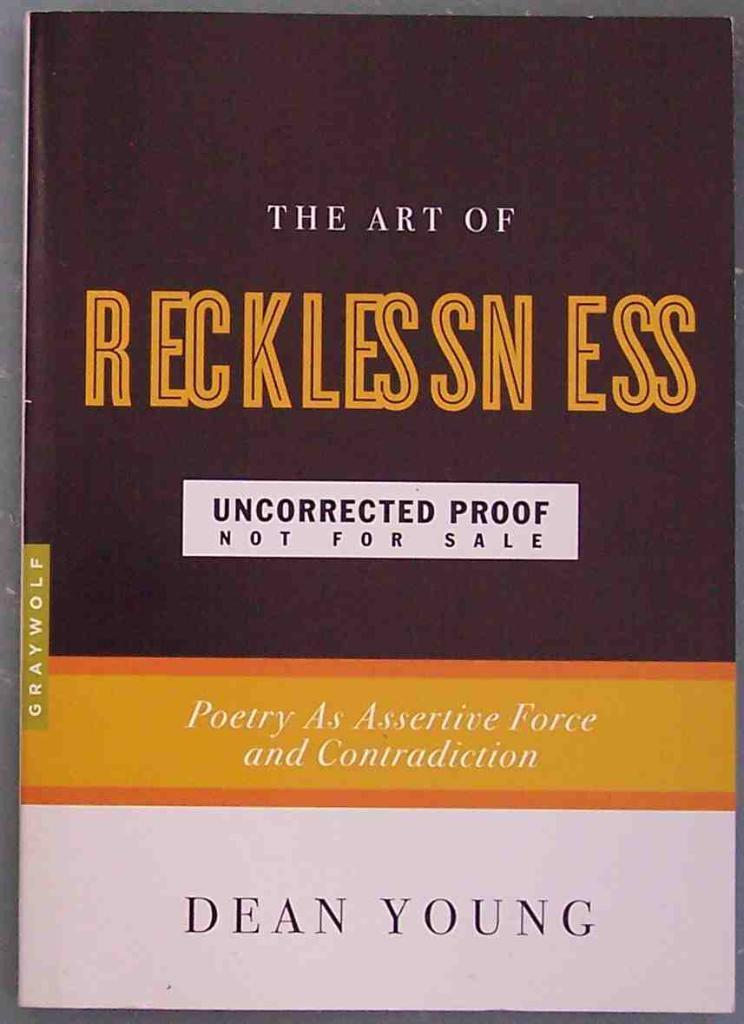<image>
Relay a brief, clear account of the picture shown. A book that is an uncorrected proof says that it is not for sale. 